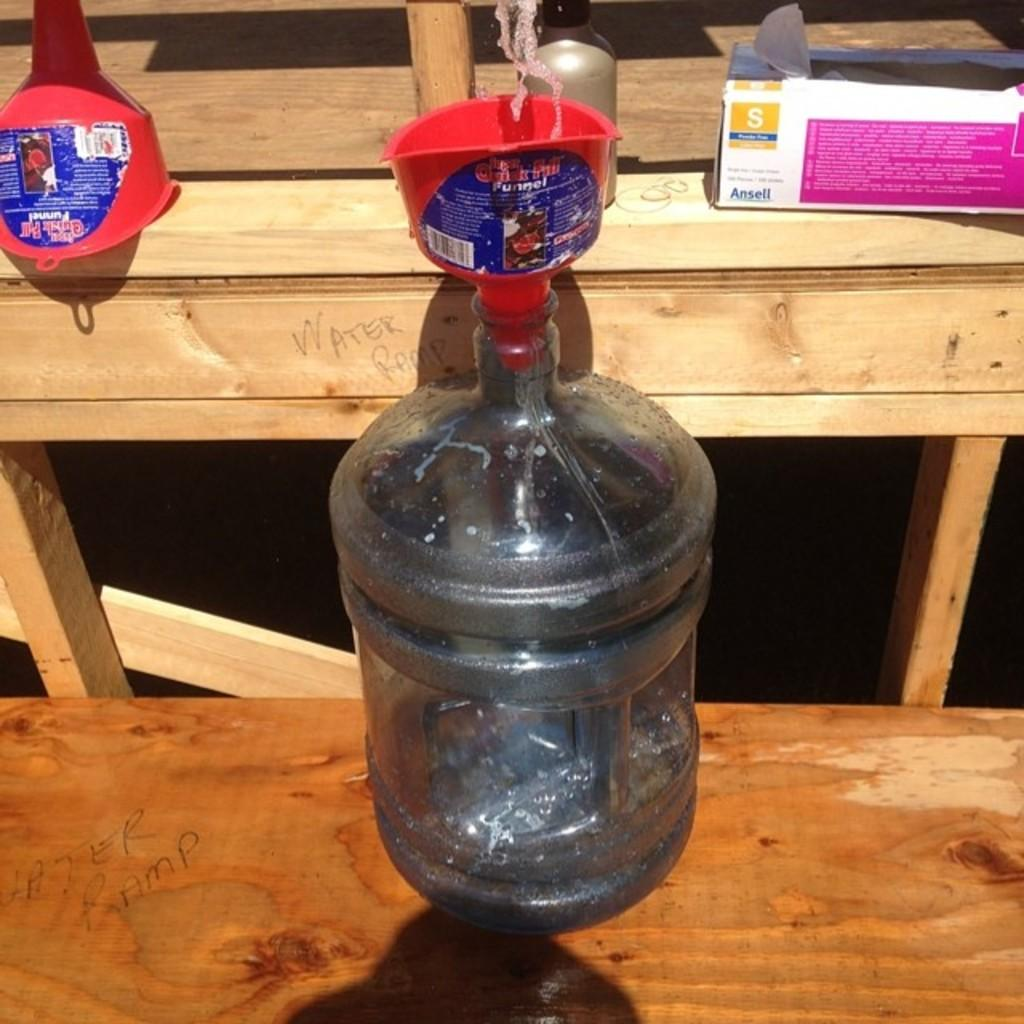What object can be seen in the image that is typically used for holding liquids? There is a bottle in the image that is typically used for holding liquids. Where is the bottle located in the image? The bottle is placed on a table in the image. What item is associated with the bottle in the image? There is a cap in the image that is associated with the bottle. What other object can be seen in the image besides the bottle and cap? There is a box in the image. What type of ear is visible on the bottle in the image? There is no ear present on the bottle in the image. 